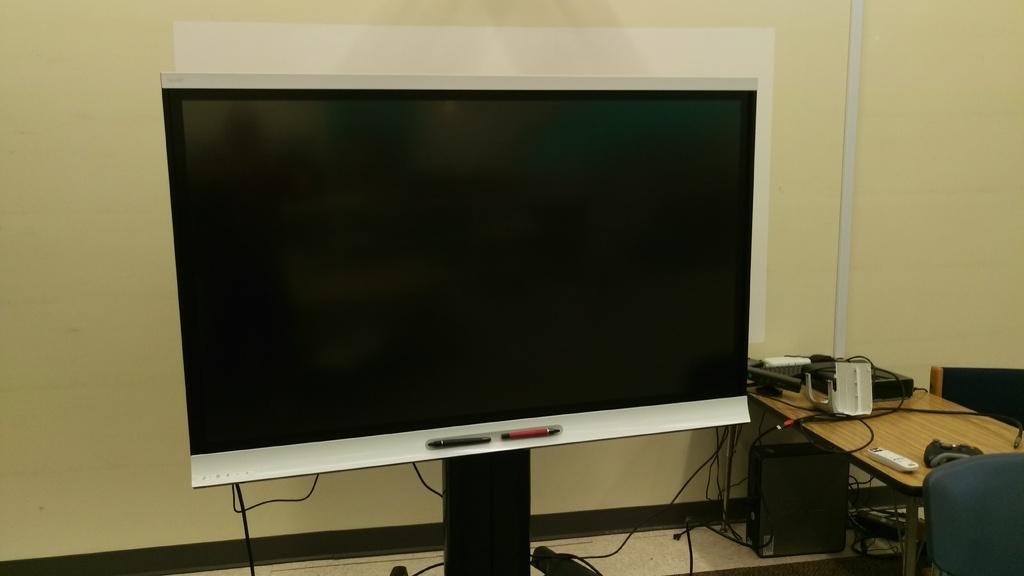Could you give a brief overview of what you see in this image? In this image there is a screen beside that there is a table and chairs also there are some boxes on it and CPU under that. 